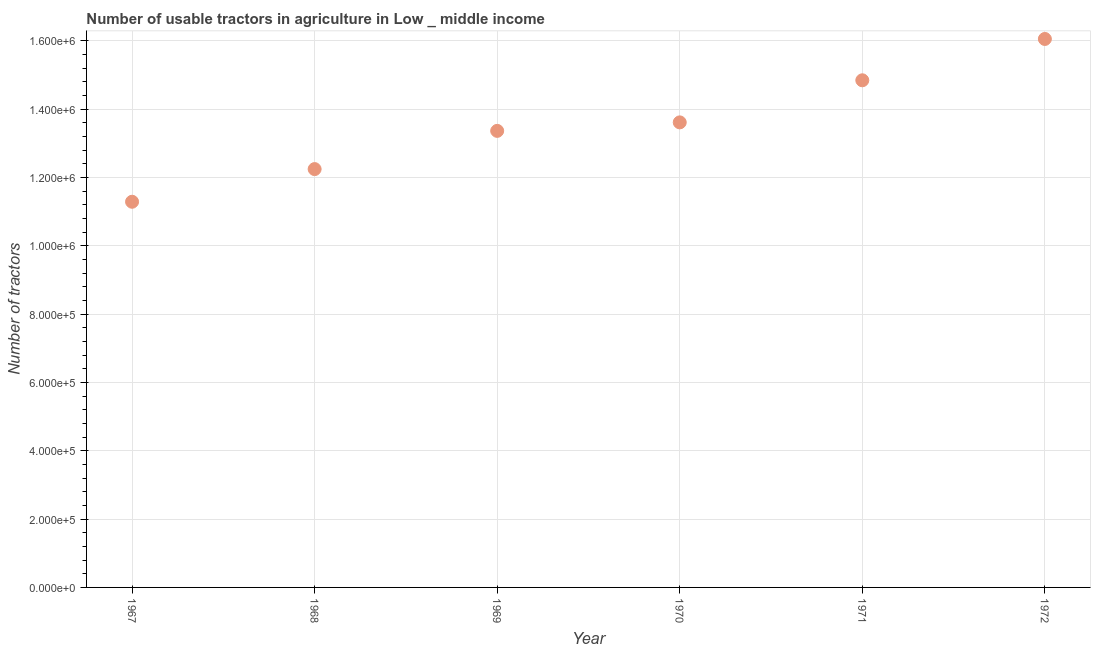What is the number of tractors in 1969?
Offer a very short reply. 1.34e+06. Across all years, what is the maximum number of tractors?
Your response must be concise. 1.61e+06. Across all years, what is the minimum number of tractors?
Your response must be concise. 1.13e+06. In which year was the number of tractors maximum?
Your answer should be very brief. 1972. In which year was the number of tractors minimum?
Make the answer very short. 1967. What is the sum of the number of tractors?
Your response must be concise. 8.14e+06. What is the difference between the number of tractors in 1969 and 1971?
Offer a terse response. -1.48e+05. What is the average number of tractors per year?
Offer a very short reply. 1.36e+06. What is the median number of tractors?
Offer a very short reply. 1.35e+06. In how many years, is the number of tractors greater than 1200000 ?
Give a very brief answer. 5. Do a majority of the years between 1969 and 1968 (inclusive) have number of tractors greater than 80000 ?
Offer a terse response. No. What is the ratio of the number of tractors in 1969 to that in 1971?
Keep it short and to the point. 0.9. Is the difference between the number of tractors in 1967 and 1971 greater than the difference between any two years?
Give a very brief answer. No. What is the difference between the highest and the second highest number of tractors?
Your answer should be very brief. 1.21e+05. Is the sum of the number of tractors in 1967 and 1970 greater than the maximum number of tractors across all years?
Your answer should be very brief. Yes. What is the difference between the highest and the lowest number of tractors?
Provide a short and direct response. 4.76e+05. In how many years, is the number of tractors greater than the average number of tractors taken over all years?
Keep it short and to the point. 3. How many dotlines are there?
Provide a succinct answer. 1. How many years are there in the graph?
Provide a short and direct response. 6. Does the graph contain any zero values?
Your answer should be very brief. No. What is the title of the graph?
Ensure brevity in your answer.  Number of usable tractors in agriculture in Low _ middle income. What is the label or title of the Y-axis?
Offer a terse response. Number of tractors. What is the Number of tractors in 1967?
Ensure brevity in your answer.  1.13e+06. What is the Number of tractors in 1968?
Give a very brief answer. 1.22e+06. What is the Number of tractors in 1969?
Give a very brief answer. 1.34e+06. What is the Number of tractors in 1970?
Offer a very short reply. 1.36e+06. What is the Number of tractors in 1971?
Your answer should be compact. 1.48e+06. What is the Number of tractors in 1972?
Provide a succinct answer. 1.61e+06. What is the difference between the Number of tractors in 1967 and 1968?
Provide a short and direct response. -9.56e+04. What is the difference between the Number of tractors in 1967 and 1969?
Keep it short and to the point. -2.07e+05. What is the difference between the Number of tractors in 1967 and 1970?
Ensure brevity in your answer.  -2.32e+05. What is the difference between the Number of tractors in 1967 and 1971?
Provide a short and direct response. -3.55e+05. What is the difference between the Number of tractors in 1967 and 1972?
Your response must be concise. -4.76e+05. What is the difference between the Number of tractors in 1968 and 1969?
Offer a very short reply. -1.12e+05. What is the difference between the Number of tractors in 1968 and 1970?
Your response must be concise. -1.37e+05. What is the difference between the Number of tractors in 1968 and 1971?
Your response must be concise. -2.60e+05. What is the difference between the Number of tractors in 1968 and 1972?
Give a very brief answer. -3.81e+05. What is the difference between the Number of tractors in 1969 and 1970?
Provide a short and direct response. -2.49e+04. What is the difference between the Number of tractors in 1969 and 1971?
Your answer should be very brief. -1.48e+05. What is the difference between the Number of tractors in 1969 and 1972?
Your answer should be compact. -2.69e+05. What is the difference between the Number of tractors in 1970 and 1971?
Make the answer very short. -1.23e+05. What is the difference between the Number of tractors in 1970 and 1972?
Your answer should be compact. -2.44e+05. What is the difference between the Number of tractors in 1971 and 1972?
Offer a terse response. -1.21e+05. What is the ratio of the Number of tractors in 1967 to that in 1968?
Your answer should be compact. 0.92. What is the ratio of the Number of tractors in 1967 to that in 1969?
Ensure brevity in your answer.  0.84. What is the ratio of the Number of tractors in 1967 to that in 1970?
Your answer should be very brief. 0.83. What is the ratio of the Number of tractors in 1967 to that in 1971?
Keep it short and to the point. 0.76. What is the ratio of the Number of tractors in 1967 to that in 1972?
Offer a terse response. 0.7. What is the ratio of the Number of tractors in 1968 to that in 1969?
Keep it short and to the point. 0.92. What is the ratio of the Number of tractors in 1968 to that in 1971?
Offer a terse response. 0.82. What is the ratio of the Number of tractors in 1968 to that in 1972?
Offer a terse response. 0.76. What is the ratio of the Number of tractors in 1969 to that in 1970?
Your response must be concise. 0.98. What is the ratio of the Number of tractors in 1969 to that in 1972?
Give a very brief answer. 0.83. What is the ratio of the Number of tractors in 1970 to that in 1971?
Make the answer very short. 0.92. What is the ratio of the Number of tractors in 1970 to that in 1972?
Provide a short and direct response. 0.85. What is the ratio of the Number of tractors in 1971 to that in 1972?
Offer a terse response. 0.93. 